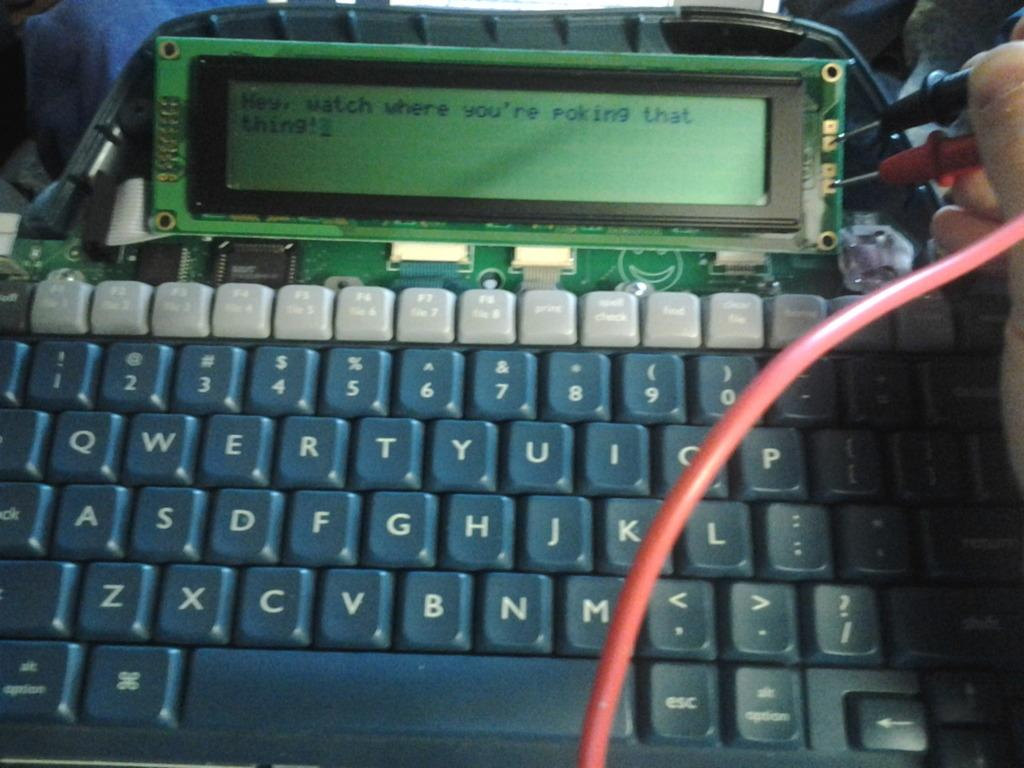<image>
Share a concise interpretation of the image provided. A word processor that someone is working on with a screen that says "Hey watch where you're poking that thing!" 